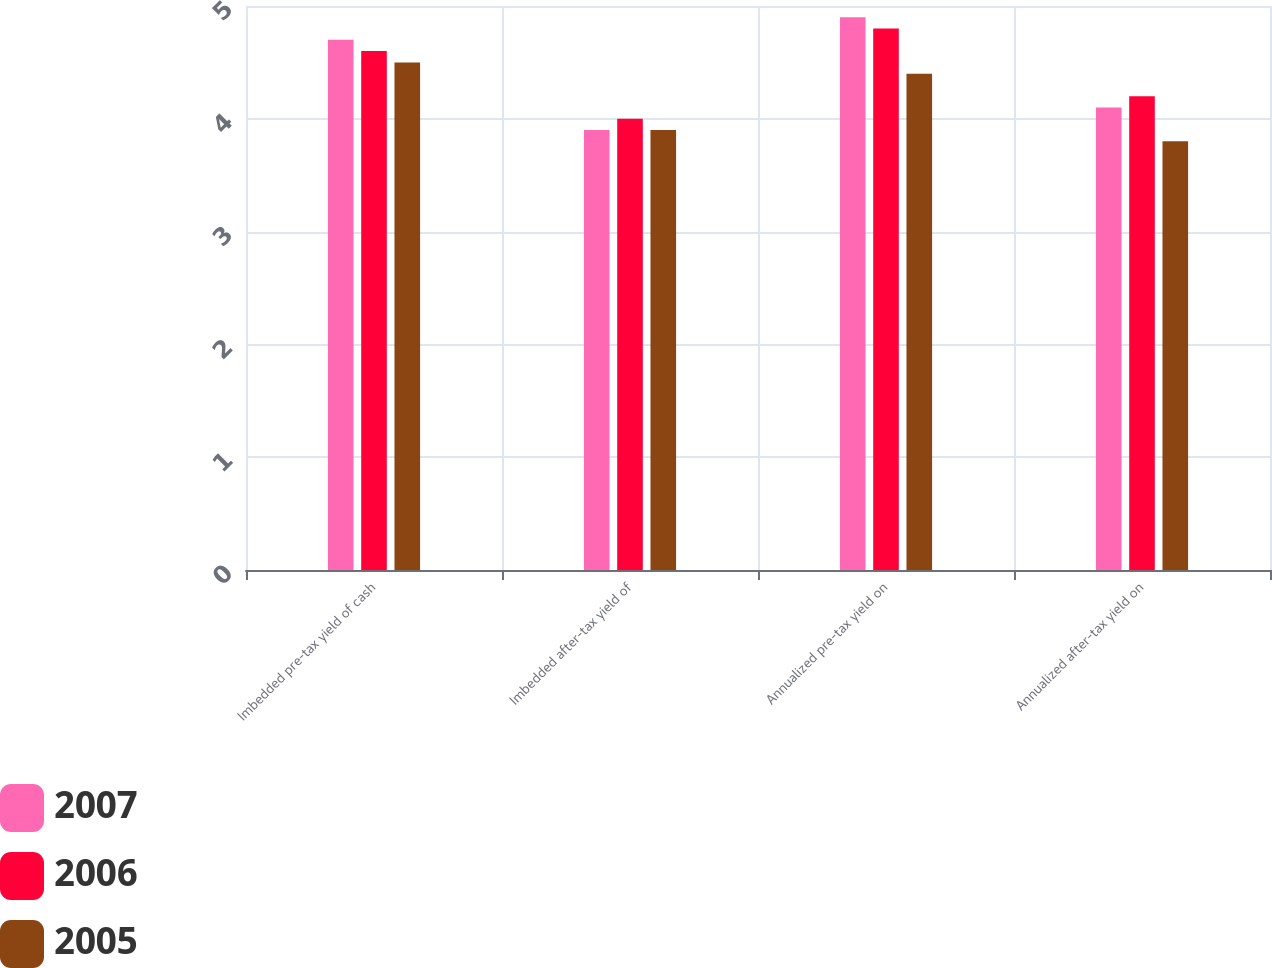Convert chart to OTSL. <chart><loc_0><loc_0><loc_500><loc_500><stacked_bar_chart><ecel><fcel>Imbedded pre-tax yield of cash<fcel>Imbedded after-tax yield of<fcel>Annualized pre-tax yield on<fcel>Annualized after-tax yield on<nl><fcel>2007<fcel>4.7<fcel>3.9<fcel>4.9<fcel>4.1<nl><fcel>2006<fcel>4.6<fcel>4<fcel>4.8<fcel>4.2<nl><fcel>2005<fcel>4.5<fcel>3.9<fcel>4.4<fcel>3.8<nl></chart> 